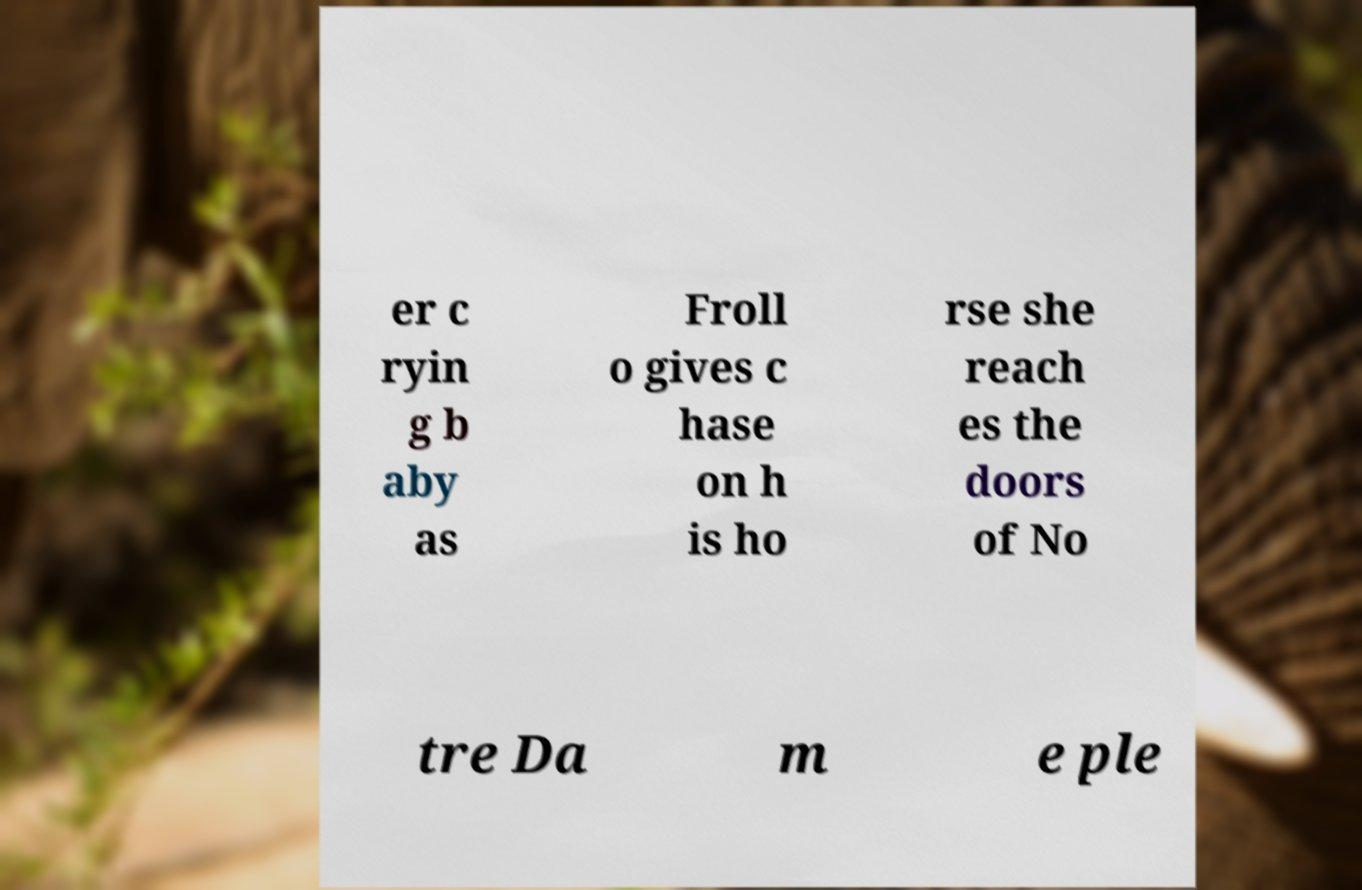Could you extract and type out the text from this image? er c ryin g b aby as Froll o gives c hase on h is ho rse she reach es the doors of No tre Da m e ple 